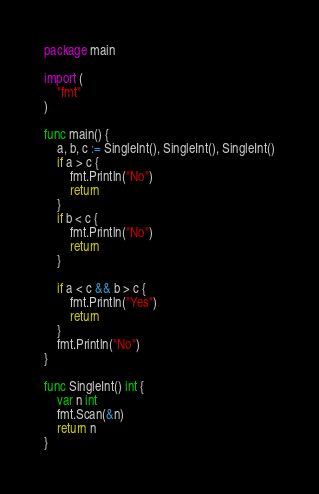Convert code to text. <code><loc_0><loc_0><loc_500><loc_500><_Go_>package main

import (
	"fmt"
)

func main() {
	a, b, c := SingleInt(), SingleInt(), SingleInt()
	if a > c {
		fmt.Println("No")
		return
	}
	if b < c {
		fmt.Println("No")
		return
	}

	if a < c && b > c {
		fmt.Println("Yes")
		return
	}
	fmt.Println("No")
}

func SingleInt() int {
	var n int
	fmt.Scan(&n)
	return n
}
</code> 